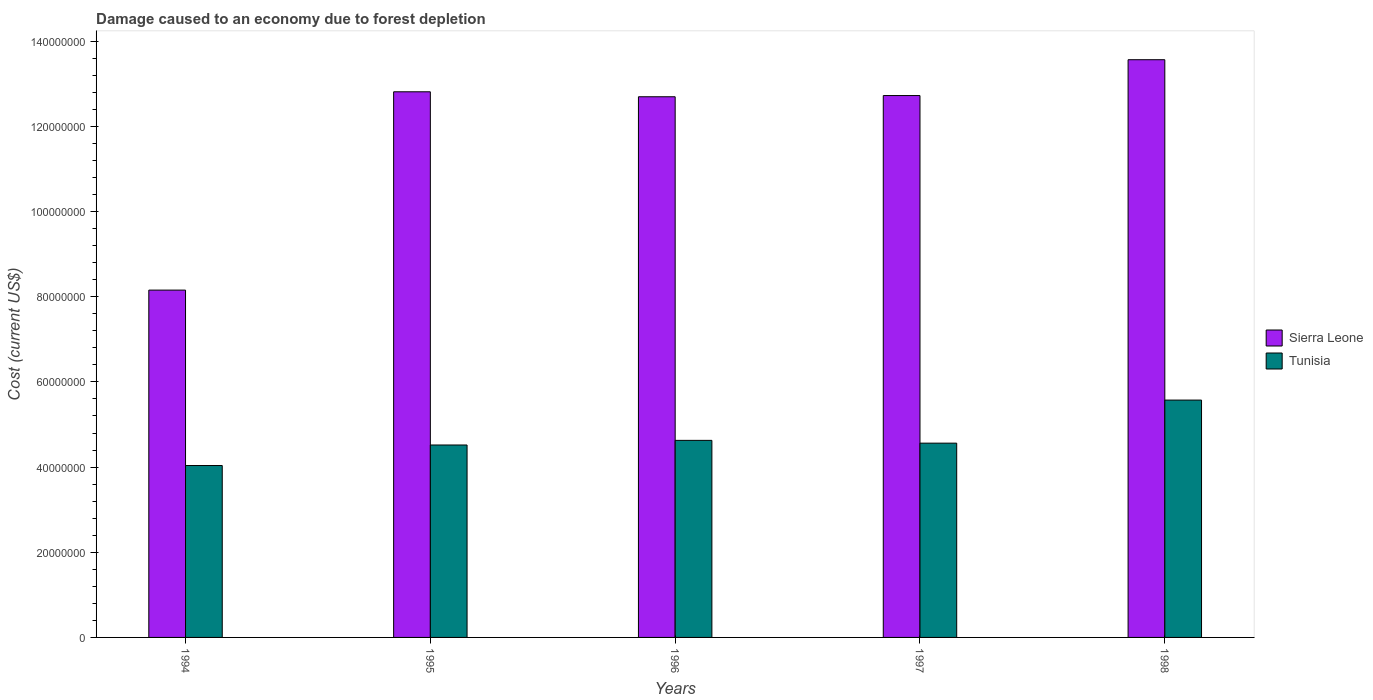How many different coloured bars are there?
Offer a very short reply. 2. How many groups of bars are there?
Offer a very short reply. 5. Are the number of bars per tick equal to the number of legend labels?
Your answer should be very brief. Yes. How many bars are there on the 1st tick from the left?
Your answer should be very brief. 2. How many bars are there on the 2nd tick from the right?
Offer a very short reply. 2. What is the cost of damage caused due to forest depletion in Sierra Leone in 1995?
Provide a succinct answer. 1.28e+08. Across all years, what is the maximum cost of damage caused due to forest depletion in Tunisia?
Ensure brevity in your answer.  5.57e+07. Across all years, what is the minimum cost of damage caused due to forest depletion in Sierra Leone?
Your answer should be very brief. 8.16e+07. In which year was the cost of damage caused due to forest depletion in Tunisia minimum?
Offer a very short reply. 1994. What is the total cost of damage caused due to forest depletion in Sierra Leone in the graph?
Keep it short and to the point. 6.00e+08. What is the difference between the cost of damage caused due to forest depletion in Tunisia in 1994 and that in 1996?
Your response must be concise. -5.91e+06. What is the difference between the cost of damage caused due to forest depletion in Tunisia in 1998 and the cost of damage caused due to forest depletion in Sierra Leone in 1994?
Give a very brief answer. -2.58e+07. What is the average cost of damage caused due to forest depletion in Tunisia per year?
Make the answer very short. 4.66e+07. In the year 1998, what is the difference between the cost of damage caused due to forest depletion in Tunisia and cost of damage caused due to forest depletion in Sierra Leone?
Keep it short and to the point. -7.99e+07. In how many years, is the cost of damage caused due to forest depletion in Tunisia greater than 60000000 US$?
Make the answer very short. 0. What is the ratio of the cost of damage caused due to forest depletion in Tunisia in 1995 to that in 1996?
Your response must be concise. 0.98. Is the difference between the cost of damage caused due to forest depletion in Tunisia in 1996 and 1997 greater than the difference between the cost of damage caused due to forest depletion in Sierra Leone in 1996 and 1997?
Your response must be concise. Yes. What is the difference between the highest and the second highest cost of damage caused due to forest depletion in Tunisia?
Offer a very short reply. 9.46e+06. What is the difference between the highest and the lowest cost of damage caused due to forest depletion in Tunisia?
Keep it short and to the point. 1.54e+07. What does the 2nd bar from the left in 1996 represents?
Your answer should be compact. Tunisia. What does the 1st bar from the right in 1994 represents?
Your answer should be very brief. Tunisia. How many years are there in the graph?
Offer a terse response. 5. What is the difference between two consecutive major ticks on the Y-axis?
Keep it short and to the point. 2.00e+07. Does the graph contain any zero values?
Ensure brevity in your answer.  No. How many legend labels are there?
Make the answer very short. 2. What is the title of the graph?
Your answer should be very brief. Damage caused to an economy due to forest depletion. Does "South Africa" appear as one of the legend labels in the graph?
Provide a succinct answer. No. What is the label or title of the X-axis?
Your answer should be compact. Years. What is the label or title of the Y-axis?
Offer a very short reply. Cost (current US$). What is the Cost (current US$) in Sierra Leone in 1994?
Provide a short and direct response. 8.16e+07. What is the Cost (current US$) in Tunisia in 1994?
Your answer should be compact. 4.04e+07. What is the Cost (current US$) of Sierra Leone in 1995?
Offer a terse response. 1.28e+08. What is the Cost (current US$) in Tunisia in 1995?
Provide a succinct answer. 4.52e+07. What is the Cost (current US$) in Sierra Leone in 1996?
Ensure brevity in your answer.  1.27e+08. What is the Cost (current US$) of Tunisia in 1996?
Provide a succinct answer. 4.63e+07. What is the Cost (current US$) of Sierra Leone in 1997?
Offer a very short reply. 1.27e+08. What is the Cost (current US$) in Tunisia in 1997?
Your answer should be compact. 4.56e+07. What is the Cost (current US$) of Sierra Leone in 1998?
Offer a terse response. 1.36e+08. What is the Cost (current US$) in Tunisia in 1998?
Your response must be concise. 5.57e+07. Across all years, what is the maximum Cost (current US$) of Sierra Leone?
Offer a very short reply. 1.36e+08. Across all years, what is the maximum Cost (current US$) of Tunisia?
Ensure brevity in your answer.  5.57e+07. Across all years, what is the minimum Cost (current US$) in Sierra Leone?
Offer a terse response. 8.16e+07. Across all years, what is the minimum Cost (current US$) of Tunisia?
Offer a very short reply. 4.04e+07. What is the total Cost (current US$) of Sierra Leone in the graph?
Your response must be concise. 6.00e+08. What is the total Cost (current US$) of Tunisia in the graph?
Keep it short and to the point. 2.33e+08. What is the difference between the Cost (current US$) of Sierra Leone in 1994 and that in 1995?
Ensure brevity in your answer.  -4.66e+07. What is the difference between the Cost (current US$) of Tunisia in 1994 and that in 1995?
Give a very brief answer. -4.82e+06. What is the difference between the Cost (current US$) in Sierra Leone in 1994 and that in 1996?
Provide a short and direct response. -4.54e+07. What is the difference between the Cost (current US$) of Tunisia in 1994 and that in 1996?
Provide a short and direct response. -5.91e+06. What is the difference between the Cost (current US$) of Sierra Leone in 1994 and that in 1997?
Ensure brevity in your answer.  -4.57e+07. What is the difference between the Cost (current US$) in Tunisia in 1994 and that in 1997?
Provide a succinct answer. -5.26e+06. What is the difference between the Cost (current US$) of Sierra Leone in 1994 and that in 1998?
Give a very brief answer. -5.41e+07. What is the difference between the Cost (current US$) in Tunisia in 1994 and that in 1998?
Your response must be concise. -1.54e+07. What is the difference between the Cost (current US$) in Sierra Leone in 1995 and that in 1996?
Make the answer very short. 1.17e+06. What is the difference between the Cost (current US$) of Tunisia in 1995 and that in 1996?
Ensure brevity in your answer.  -1.09e+06. What is the difference between the Cost (current US$) of Sierra Leone in 1995 and that in 1997?
Your answer should be compact. 8.83e+05. What is the difference between the Cost (current US$) in Tunisia in 1995 and that in 1997?
Your answer should be compact. -4.33e+05. What is the difference between the Cost (current US$) of Sierra Leone in 1995 and that in 1998?
Provide a succinct answer. -7.53e+06. What is the difference between the Cost (current US$) in Tunisia in 1995 and that in 1998?
Your response must be concise. -1.05e+07. What is the difference between the Cost (current US$) in Sierra Leone in 1996 and that in 1997?
Provide a short and direct response. -2.82e+05. What is the difference between the Cost (current US$) of Tunisia in 1996 and that in 1997?
Offer a very short reply. 6.54e+05. What is the difference between the Cost (current US$) in Sierra Leone in 1996 and that in 1998?
Make the answer very short. -8.70e+06. What is the difference between the Cost (current US$) of Tunisia in 1996 and that in 1998?
Your answer should be compact. -9.46e+06. What is the difference between the Cost (current US$) in Sierra Leone in 1997 and that in 1998?
Keep it short and to the point. -8.42e+06. What is the difference between the Cost (current US$) of Tunisia in 1997 and that in 1998?
Provide a short and direct response. -1.01e+07. What is the difference between the Cost (current US$) in Sierra Leone in 1994 and the Cost (current US$) in Tunisia in 1995?
Your response must be concise. 3.64e+07. What is the difference between the Cost (current US$) of Sierra Leone in 1994 and the Cost (current US$) of Tunisia in 1996?
Offer a very short reply. 3.53e+07. What is the difference between the Cost (current US$) of Sierra Leone in 1994 and the Cost (current US$) of Tunisia in 1997?
Your answer should be very brief. 3.59e+07. What is the difference between the Cost (current US$) in Sierra Leone in 1994 and the Cost (current US$) in Tunisia in 1998?
Provide a succinct answer. 2.58e+07. What is the difference between the Cost (current US$) in Sierra Leone in 1995 and the Cost (current US$) in Tunisia in 1996?
Make the answer very short. 8.19e+07. What is the difference between the Cost (current US$) of Sierra Leone in 1995 and the Cost (current US$) of Tunisia in 1997?
Provide a short and direct response. 8.25e+07. What is the difference between the Cost (current US$) of Sierra Leone in 1995 and the Cost (current US$) of Tunisia in 1998?
Your answer should be compact. 7.24e+07. What is the difference between the Cost (current US$) in Sierra Leone in 1996 and the Cost (current US$) in Tunisia in 1997?
Your answer should be compact. 8.13e+07. What is the difference between the Cost (current US$) of Sierra Leone in 1996 and the Cost (current US$) of Tunisia in 1998?
Provide a short and direct response. 7.12e+07. What is the difference between the Cost (current US$) in Sierra Leone in 1997 and the Cost (current US$) in Tunisia in 1998?
Give a very brief answer. 7.15e+07. What is the average Cost (current US$) of Sierra Leone per year?
Keep it short and to the point. 1.20e+08. What is the average Cost (current US$) in Tunisia per year?
Ensure brevity in your answer.  4.66e+07. In the year 1994, what is the difference between the Cost (current US$) of Sierra Leone and Cost (current US$) of Tunisia?
Your answer should be compact. 4.12e+07. In the year 1995, what is the difference between the Cost (current US$) of Sierra Leone and Cost (current US$) of Tunisia?
Offer a very short reply. 8.29e+07. In the year 1996, what is the difference between the Cost (current US$) in Sierra Leone and Cost (current US$) in Tunisia?
Offer a very short reply. 8.07e+07. In the year 1997, what is the difference between the Cost (current US$) in Sierra Leone and Cost (current US$) in Tunisia?
Provide a short and direct response. 8.16e+07. In the year 1998, what is the difference between the Cost (current US$) in Sierra Leone and Cost (current US$) in Tunisia?
Keep it short and to the point. 7.99e+07. What is the ratio of the Cost (current US$) of Sierra Leone in 1994 to that in 1995?
Ensure brevity in your answer.  0.64. What is the ratio of the Cost (current US$) in Tunisia in 1994 to that in 1995?
Your response must be concise. 0.89. What is the ratio of the Cost (current US$) of Sierra Leone in 1994 to that in 1996?
Offer a terse response. 0.64. What is the ratio of the Cost (current US$) in Tunisia in 1994 to that in 1996?
Keep it short and to the point. 0.87. What is the ratio of the Cost (current US$) of Sierra Leone in 1994 to that in 1997?
Your answer should be very brief. 0.64. What is the ratio of the Cost (current US$) in Tunisia in 1994 to that in 1997?
Ensure brevity in your answer.  0.88. What is the ratio of the Cost (current US$) in Sierra Leone in 1994 to that in 1998?
Keep it short and to the point. 0.6. What is the ratio of the Cost (current US$) of Tunisia in 1994 to that in 1998?
Make the answer very short. 0.72. What is the ratio of the Cost (current US$) of Sierra Leone in 1995 to that in 1996?
Offer a terse response. 1.01. What is the ratio of the Cost (current US$) of Tunisia in 1995 to that in 1996?
Your answer should be very brief. 0.98. What is the ratio of the Cost (current US$) in Sierra Leone in 1995 to that in 1997?
Keep it short and to the point. 1.01. What is the ratio of the Cost (current US$) in Sierra Leone in 1995 to that in 1998?
Your answer should be very brief. 0.94. What is the ratio of the Cost (current US$) in Tunisia in 1995 to that in 1998?
Provide a short and direct response. 0.81. What is the ratio of the Cost (current US$) in Sierra Leone in 1996 to that in 1997?
Your answer should be compact. 1. What is the ratio of the Cost (current US$) of Tunisia in 1996 to that in 1997?
Give a very brief answer. 1.01. What is the ratio of the Cost (current US$) of Sierra Leone in 1996 to that in 1998?
Offer a very short reply. 0.94. What is the ratio of the Cost (current US$) in Tunisia in 1996 to that in 1998?
Your answer should be compact. 0.83. What is the ratio of the Cost (current US$) in Sierra Leone in 1997 to that in 1998?
Give a very brief answer. 0.94. What is the ratio of the Cost (current US$) in Tunisia in 1997 to that in 1998?
Provide a succinct answer. 0.82. What is the difference between the highest and the second highest Cost (current US$) of Sierra Leone?
Your answer should be very brief. 7.53e+06. What is the difference between the highest and the second highest Cost (current US$) in Tunisia?
Your response must be concise. 9.46e+06. What is the difference between the highest and the lowest Cost (current US$) of Sierra Leone?
Keep it short and to the point. 5.41e+07. What is the difference between the highest and the lowest Cost (current US$) in Tunisia?
Provide a short and direct response. 1.54e+07. 